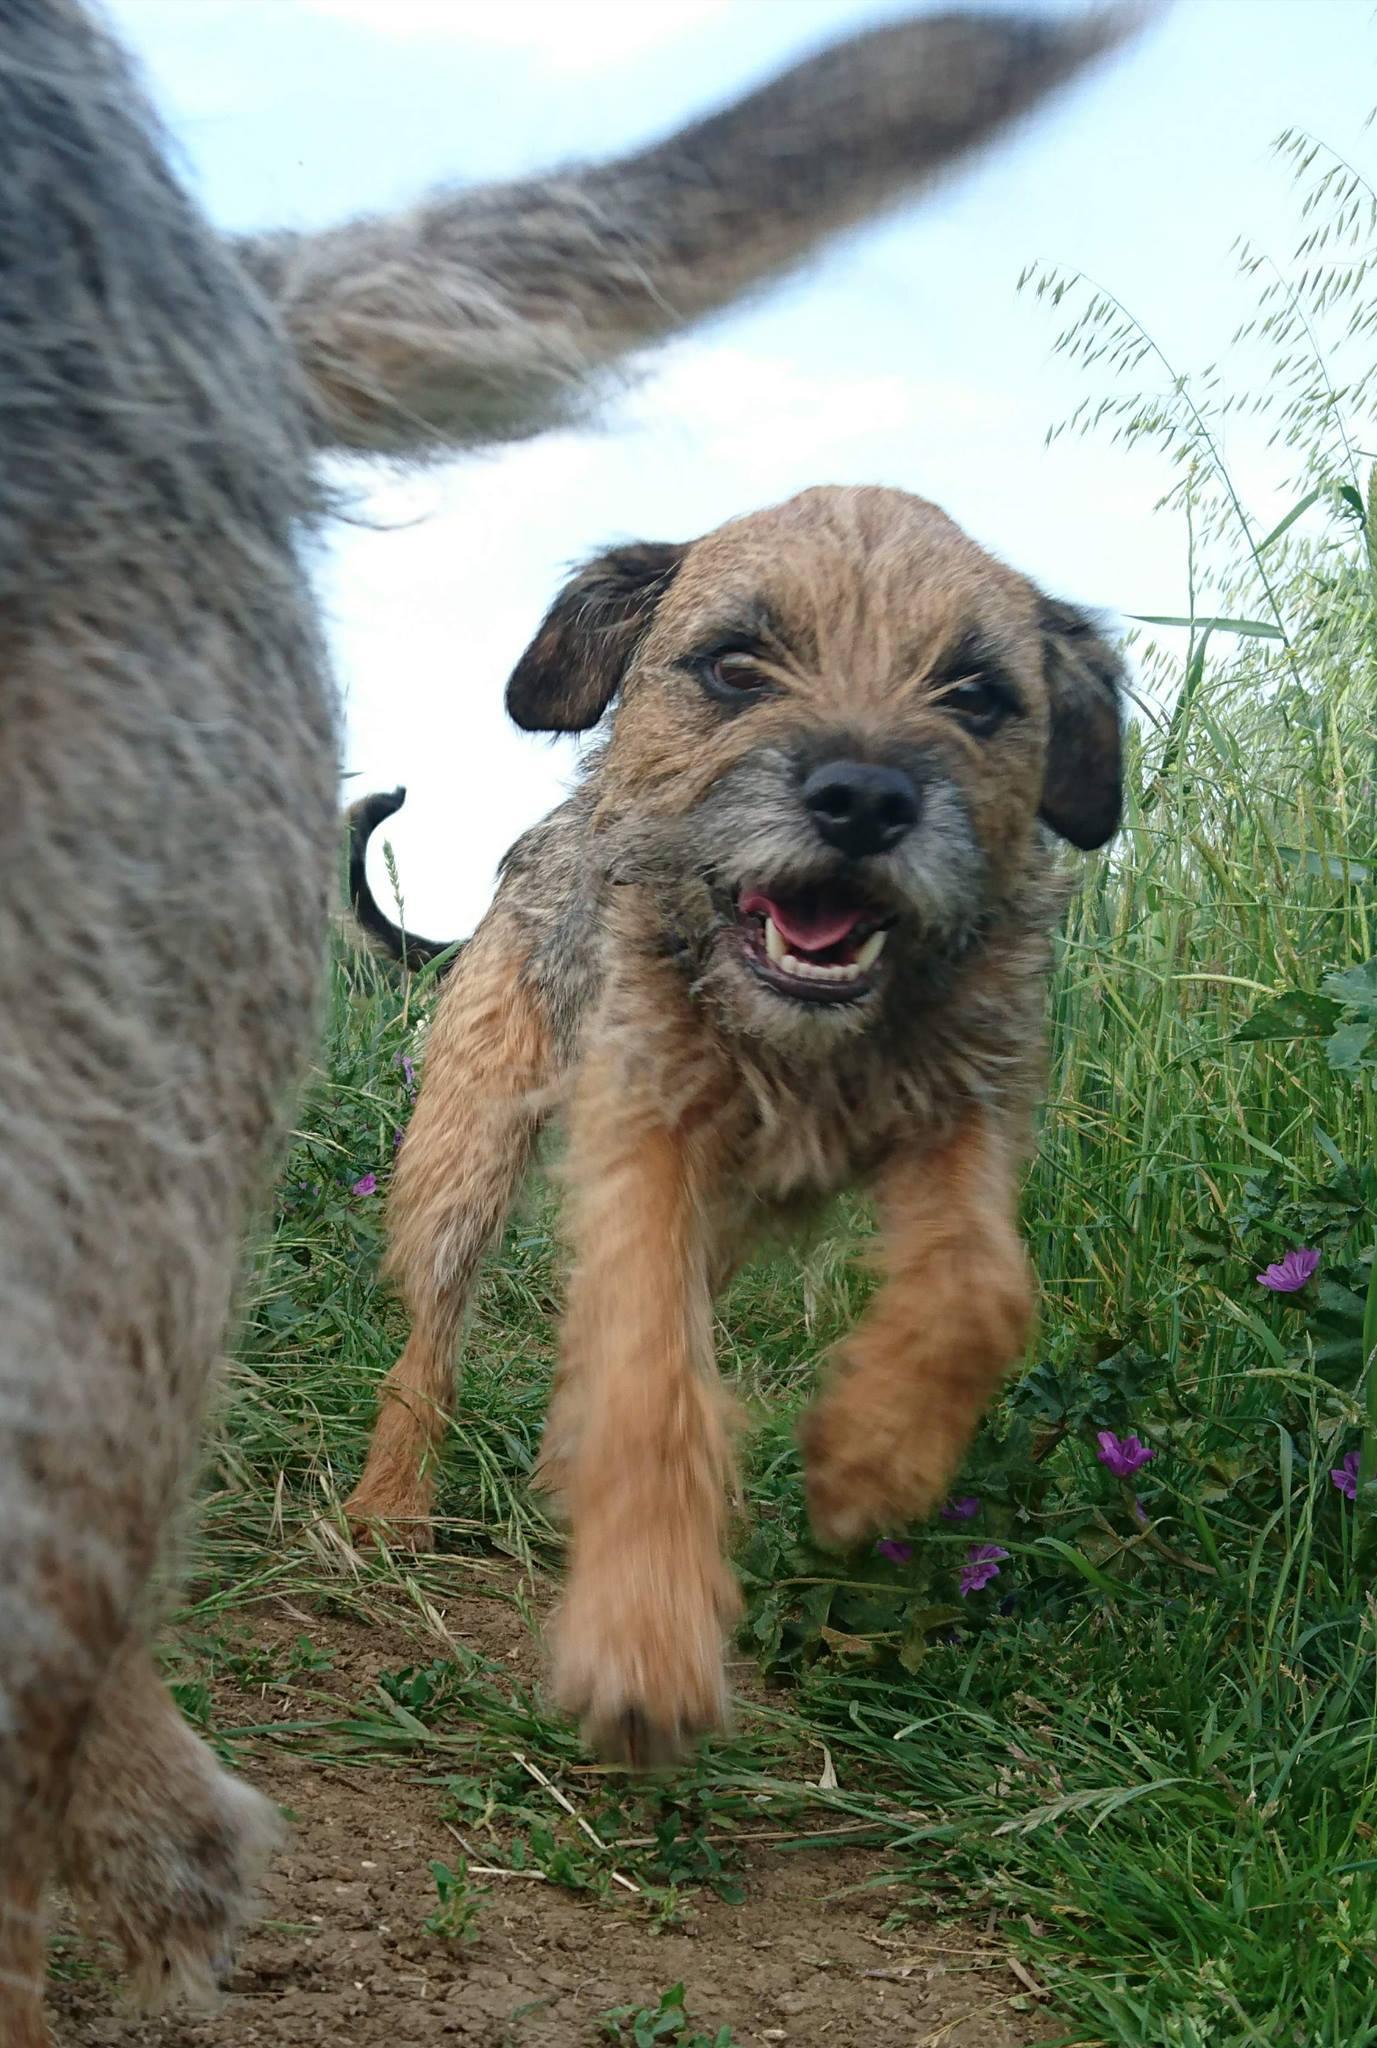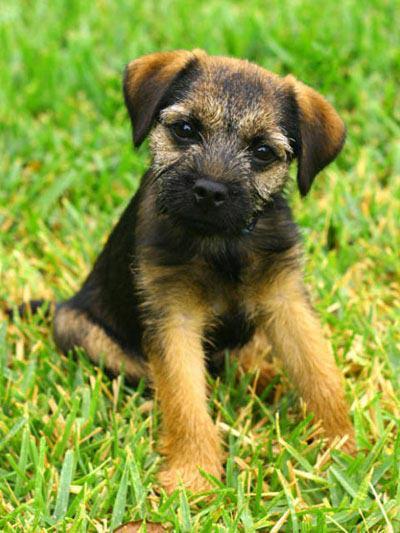The first image is the image on the left, the second image is the image on the right. Analyze the images presented: Is the assertion "Each dog is outside in the grass." valid? Answer yes or no. Yes. The first image is the image on the left, the second image is the image on the right. Considering the images on both sides, is "Each image shows the face of one dog, but only the lefthand image features a dog with an open mouth." valid? Answer yes or no. Yes. 